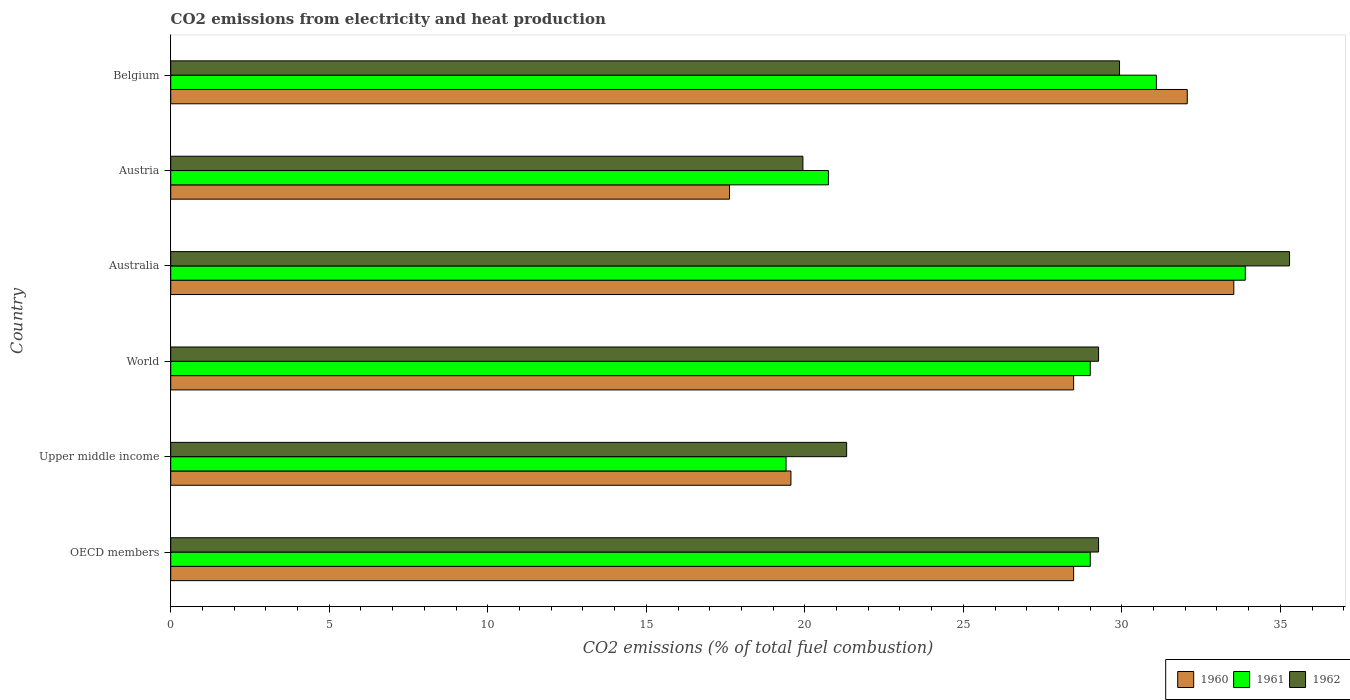How many different coloured bars are there?
Your answer should be very brief. 3. How many groups of bars are there?
Your answer should be very brief. 6. Are the number of bars on each tick of the Y-axis equal?
Provide a short and direct response. Yes. How many bars are there on the 5th tick from the top?
Provide a succinct answer. 3. What is the label of the 5th group of bars from the top?
Keep it short and to the point. Upper middle income. What is the amount of CO2 emitted in 1962 in OECD members?
Keep it short and to the point. 29.26. Across all countries, what is the maximum amount of CO2 emitted in 1961?
Your response must be concise. 33.89. Across all countries, what is the minimum amount of CO2 emitted in 1960?
Keep it short and to the point. 17.63. In which country was the amount of CO2 emitted in 1960 maximum?
Your answer should be very brief. Australia. In which country was the amount of CO2 emitted in 1962 minimum?
Provide a short and direct response. Austria. What is the total amount of CO2 emitted in 1961 in the graph?
Offer a terse response. 163.15. What is the difference between the amount of CO2 emitted in 1962 in Austria and that in Upper middle income?
Give a very brief answer. -1.38. What is the difference between the amount of CO2 emitted in 1960 in Upper middle income and the amount of CO2 emitted in 1961 in Austria?
Provide a succinct answer. -1.18. What is the average amount of CO2 emitted in 1960 per country?
Provide a succinct answer. 26.62. What is the difference between the amount of CO2 emitted in 1962 and amount of CO2 emitted in 1961 in Upper middle income?
Ensure brevity in your answer.  1.91. What is the ratio of the amount of CO2 emitted in 1962 in Australia to that in OECD members?
Give a very brief answer. 1.21. What is the difference between the highest and the second highest amount of CO2 emitted in 1962?
Offer a very short reply. 5.36. What is the difference between the highest and the lowest amount of CO2 emitted in 1960?
Keep it short and to the point. 15.91. What does the 3rd bar from the bottom in Upper middle income represents?
Your response must be concise. 1962. Is it the case that in every country, the sum of the amount of CO2 emitted in 1960 and amount of CO2 emitted in 1961 is greater than the amount of CO2 emitted in 1962?
Offer a very short reply. Yes. How many bars are there?
Provide a succinct answer. 18. How many countries are there in the graph?
Your answer should be compact. 6. Does the graph contain any zero values?
Offer a very short reply. No. Does the graph contain grids?
Your response must be concise. No. Where does the legend appear in the graph?
Offer a very short reply. Bottom right. What is the title of the graph?
Offer a terse response. CO2 emissions from electricity and heat production. What is the label or title of the X-axis?
Provide a succinct answer. CO2 emissions (% of total fuel combustion). What is the label or title of the Y-axis?
Offer a terse response. Country. What is the CO2 emissions (% of total fuel combustion) of 1960 in OECD members?
Ensure brevity in your answer.  28.48. What is the CO2 emissions (% of total fuel combustion) of 1961 in OECD members?
Keep it short and to the point. 29. What is the CO2 emissions (% of total fuel combustion) in 1962 in OECD members?
Keep it short and to the point. 29.26. What is the CO2 emissions (% of total fuel combustion) in 1960 in Upper middle income?
Offer a terse response. 19.56. What is the CO2 emissions (% of total fuel combustion) of 1961 in Upper middle income?
Ensure brevity in your answer.  19.41. What is the CO2 emissions (% of total fuel combustion) of 1962 in Upper middle income?
Your response must be concise. 21.32. What is the CO2 emissions (% of total fuel combustion) of 1960 in World?
Your answer should be very brief. 28.48. What is the CO2 emissions (% of total fuel combustion) in 1961 in World?
Ensure brevity in your answer.  29. What is the CO2 emissions (% of total fuel combustion) in 1962 in World?
Provide a succinct answer. 29.26. What is the CO2 emissions (% of total fuel combustion) in 1960 in Australia?
Your answer should be very brief. 33.53. What is the CO2 emissions (% of total fuel combustion) of 1961 in Australia?
Your response must be concise. 33.89. What is the CO2 emissions (% of total fuel combustion) of 1962 in Australia?
Provide a short and direct response. 35.29. What is the CO2 emissions (% of total fuel combustion) in 1960 in Austria?
Ensure brevity in your answer.  17.63. What is the CO2 emissions (% of total fuel combustion) in 1961 in Austria?
Offer a very short reply. 20.75. What is the CO2 emissions (% of total fuel combustion) in 1962 in Austria?
Keep it short and to the point. 19.94. What is the CO2 emissions (% of total fuel combustion) of 1960 in Belgium?
Your answer should be very brief. 32.06. What is the CO2 emissions (% of total fuel combustion) in 1961 in Belgium?
Provide a short and direct response. 31.09. What is the CO2 emissions (% of total fuel combustion) of 1962 in Belgium?
Offer a very short reply. 29.93. Across all countries, what is the maximum CO2 emissions (% of total fuel combustion) of 1960?
Your answer should be very brief. 33.53. Across all countries, what is the maximum CO2 emissions (% of total fuel combustion) of 1961?
Make the answer very short. 33.89. Across all countries, what is the maximum CO2 emissions (% of total fuel combustion) in 1962?
Keep it short and to the point. 35.29. Across all countries, what is the minimum CO2 emissions (% of total fuel combustion) of 1960?
Keep it short and to the point. 17.63. Across all countries, what is the minimum CO2 emissions (% of total fuel combustion) of 1961?
Your response must be concise. 19.41. Across all countries, what is the minimum CO2 emissions (% of total fuel combustion) in 1962?
Make the answer very short. 19.94. What is the total CO2 emissions (% of total fuel combustion) in 1960 in the graph?
Offer a very short reply. 159.74. What is the total CO2 emissions (% of total fuel combustion) in 1961 in the graph?
Your answer should be compact. 163.15. What is the total CO2 emissions (% of total fuel combustion) in 1962 in the graph?
Keep it short and to the point. 165.01. What is the difference between the CO2 emissions (% of total fuel combustion) of 1960 in OECD members and that in Upper middle income?
Make the answer very short. 8.92. What is the difference between the CO2 emissions (% of total fuel combustion) of 1961 in OECD members and that in Upper middle income?
Ensure brevity in your answer.  9.6. What is the difference between the CO2 emissions (% of total fuel combustion) of 1962 in OECD members and that in Upper middle income?
Your answer should be very brief. 7.95. What is the difference between the CO2 emissions (% of total fuel combustion) of 1962 in OECD members and that in World?
Make the answer very short. 0. What is the difference between the CO2 emissions (% of total fuel combustion) in 1960 in OECD members and that in Australia?
Make the answer very short. -5.05. What is the difference between the CO2 emissions (% of total fuel combustion) of 1961 in OECD members and that in Australia?
Give a very brief answer. -4.89. What is the difference between the CO2 emissions (% of total fuel combustion) of 1962 in OECD members and that in Australia?
Your response must be concise. -6.02. What is the difference between the CO2 emissions (% of total fuel combustion) of 1960 in OECD members and that in Austria?
Your response must be concise. 10.85. What is the difference between the CO2 emissions (% of total fuel combustion) of 1961 in OECD members and that in Austria?
Give a very brief answer. 8.26. What is the difference between the CO2 emissions (% of total fuel combustion) of 1962 in OECD members and that in Austria?
Provide a succinct answer. 9.33. What is the difference between the CO2 emissions (% of total fuel combustion) of 1960 in OECD members and that in Belgium?
Provide a short and direct response. -3.58. What is the difference between the CO2 emissions (% of total fuel combustion) in 1961 in OECD members and that in Belgium?
Keep it short and to the point. -2.09. What is the difference between the CO2 emissions (% of total fuel combustion) of 1962 in OECD members and that in Belgium?
Ensure brevity in your answer.  -0.66. What is the difference between the CO2 emissions (% of total fuel combustion) of 1960 in Upper middle income and that in World?
Provide a succinct answer. -8.92. What is the difference between the CO2 emissions (% of total fuel combustion) of 1961 in Upper middle income and that in World?
Give a very brief answer. -9.6. What is the difference between the CO2 emissions (% of total fuel combustion) of 1962 in Upper middle income and that in World?
Keep it short and to the point. -7.95. What is the difference between the CO2 emissions (% of total fuel combustion) in 1960 in Upper middle income and that in Australia?
Ensure brevity in your answer.  -13.97. What is the difference between the CO2 emissions (% of total fuel combustion) of 1961 in Upper middle income and that in Australia?
Your response must be concise. -14.49. What is the difference between the CO2 emissions (% of total fuel combustion) of 1962 in Upper middle income and that in Australia?
Offer a terse response. -13.97. What is the difference between the CO2 emissions (% of total fuel combustion) in 1960 in Upper middle income and that in Austria?
Your response must be concise. 1.94. What is the difference between the CO2 emissions (% of total fuel combustion) of 1961 in Upper middle income and that in Austria?
Provide a short and direct response. -1.34. What is the difference between the CO2 emissions (% of total fuel combustion) in 1962 in Upper middle income and that in Austria?
Your response must be concise. 1.38. What is the difference between the CO2 emissions (% of total fuel combustion) in 1960 in Upper middle income and that in Belgium?
Your answer should be compact. -12.5. What is the difference between the CO2 emissions (% of total fuel combustion) of 1961 in Upper middle income and that in Belgium?
Your answer should be very brief. -11.68. What is the difference between the CO2 emissions (% of total fuel combustion) in 1962 in Upper middle income and that in Belgium?
Your response must be concise. -8.61. What is the difference between the CO2 emissions (% of total fuel combustion) of 1960 in World and that in Australia?
Your response must be concise. -5.05. What is the difference between the CO2 emissions (% of total fuel combustion) of 1961 in World and that in Australia?
Make the answer very short. -4.89. What is the difference between the CO2 emissions (% of total fuel combustion) of 1962 in World and that in Australia?
Offer a very short reply. -6.02. What is the difference between the CO2 emissions (% of total fuel combustion) of 1960 in World and that in Austria?
Offer a very short reply. 10.85. What is the difference between the CO2 emissions (% of total fuel combustion) in 1961 in World and that in Austria?
Your answer should be compact. 8.26. What is the difference between the CO2 emissions (% of total fuel combustion) in 1962 in World and that in Austria?
Your answer should be compact. 9.33. What is the difference between the CO2 emissions (% of total fuel combustion) in 1960 in World and that in Belgium?
Ensure brevity in your answer.  -3.58. What is the difference between the CO2 emissions (% of total fuel combustion) in 1961 in World and that in Belgium?
Give a very brief answer. -2.09. What is the difference between the CO2 emissions (% of total fuel combustion) in 1962 in World and that in Belgium?
Your answer should be compact. -0.66. What is the difference between the CO2 emissions (% of total fuel combustion) in 1960 in Australia and that in Austria?
Keep it short and to the point. 15.91. What is the difference between the CO2 emissions (% of total fuel combustion) in 1961 in Australia and that in Austria?
Offer a terse response. 13.15. What is the difference between the CO2 emissions (% of total fuel combustion) in 1962 in Australia and that in Austria?
Provide a short and direct response. 15.35. What is the difference between the CO2 emissions (% of total fuel combustion) of 1960 in Australia and that in Belgium?
Offer a terse response. 1.47. What is the difference between the CO2 emissions (% of total fuel combustion) in 1961 in Australia and that in Belgium?
Your answer should be compact. 2.8. What is the difference between the CO2 emissions (% of total fuel combustion) of 1962 in Australia and that in Belgium?
Keep it short and to the point. 5.36. What is the difference between the CO2 emissions (% of total fuel combustion) of 1960 in Austria and that in Belgium?
Give a very brief answer. -14.44. What is the difference between the CO2 emissions (% of total fuel combustion) in 1961 in Austria and that in Belgium?
Your answer should be compact. -10.34. What is the difference between the CO2 emissions (% of total fuel combustion) in 1962 in Austria and that in Belgium?
Provide a short and direct response. -9.99. What is the difference between the CO2 emissions (% of total fuel combustion) of 1960 in OECD members and the CO2 emissions (% of total fuel combustion) of 1961 in Upper middle income?
Give a very brief answer. 9.07. What is the difference between the CO2 emissions (% of total fuel combustion) of 1960 in OECD members and the CO2 emissions (% of total fuel combustion) of 1962 in Upper middle income?
Offer a very short reply. 7.16. What is the difference between the CO2 emissions (% of total fuel combustion) of 1961 in OECD members and the CO2 emissions (% of total fuel combustion) of 1962 in Upper middle income?
Provide a succinct answer. 7.68. What is the difference between the CO2 emissions (% of total fuel combustion) in 1960 in OECD members and the CO2 emissions (% of total fuel combustion) in 1961 in World?
Your answer should be compact. -0.52. What is the difference between the CO2 emissions (% of total fuel combustion) in 1960 in OECD members and the CO2 emissions (% of total fuel combustion) in 1962 in World?
Your answer should be very brief. -0.79. What is the difference between the CO2 emissions (% of total fuel combustion) in 1961 in OECD members and the CO2 emissions (% of total fuel combustion) in 1962 in World?
Ensure brevity in your answer.  -0.26. What is the difference between the CO2 emissions (% of total fuel combustion) in 1960 in OECD members and the CO2 emissions (% of total fuel combustion) in 1961 in Australia?
Make the answer very short. -5.41. What is the difference between the CO2 emissions (% of total fuel combustion) in 1960 in OECD members and the CO2 emissions (% of total fuel combustion) in 1962 in Australia?
Your answer should be compact. -6.81. What is the difference between the CO2 emissions (% of total fuel combustion) of 1961 in OECD members and the CO2 emissions (% of total fuel combustion) of 1962 in Australia?
Offer a very short reply. -6.29. What is the difference between the CO2 emissions (% of total fuel combustion) in 1960 in OECD members and the CO2 emissions (% of total fuel combustion) in 1961 in Austria?
Provide a succinct answer. 7.73. What is the difference between the CO2 emissions (% of total fuel combustion) of 1960 in OECD members and the CO2 emissions (% of total fuel combustion) of 1962 in Austria?
Offer a terse response. 8.54. What is the difference between the CO2 emissions (% of total fuel combustion) in 1961 in OECD members and the CO2 emissions (% of total fuel combustion) in 1962 in Austria?
Offer a very short reply. 9.06. What is the difference between the CO2 emissions (% of total fuel combustion) of 1960 in OECD members and the CO2 emissions (% of total fuel combustion) of 1961 in Belgium?
Provide a succinct answer. -2.61. What is the difference between the CO2 emissions (% of total fuel combustion) in 1960 in OECD members and the CO2 emissions (% of total fuel combustion) in 1962 in Belgium?
Offer a very short reply. -1.45. What is the difference between the CO2 emissions (% of total fuel combustion) of 1961 in OECD members and the CO2 emissions (% of total fuel combustion) of 1962 in Belgium?
Keep it short and to the point. -0.92. What is the difference between the CO2 emissions (% of total fuel combustion) of 1960 in Upper middle income and the CO2 emissions (% of total fuel combustion) of 1961 in World?
Provide a succinct answer. -9.44. What is the difference between the CO2 emissions (% of total fuel combustion) of 1960 in Upper middle income and the CO2 emissions (% of total fuel combustion) of 1962 in World?
Provide a succinct answer. -9.7. What is the difference between the CO2 emissions (% of total fuel combustion) of 1961 in Upper middle income and the CO2 emissions (% of total fuel combustion) of 1962 in World?
Offer a very short reply. -9.86. What is the difference between the CO2 emissions (% of total fuel combustion) of 1960 in Upper middle income and the CO2 emissions (% of total fuel combustion) of 1961 in Australia?
Your answer should be very brief. -14.33. What is the difference between the CO2 emissions (% of total fuel combustion) in 1960 in Upper middle income and the CO2 emissions (% of total fuel combustion) in 1962 in Australia?
Your answer should be very brief. -15.73. What is the difference between the CO2 emissions (% of total fuel combustion) of 1961 in Upper middle income and the CO2 emissions (% of total fuel combustion) of 1962 in Australia?
Your answer should be compact. -15.88. What is the difference between the CO2 emissions (% of total fuel combustion) in 1960 in Upper middle income and the CO2 emissions (% of total fuel combustion) in 1961 in Austria?
Give a very brief answer. -1.18. What is the difference between the CO2 emissions (% of total fuel combustion) of 1960 in Upper middle income and the CO2 emissions (% of total fuel combustion) of 1962 in Austria?
Make the answer very short. -0.38. What is the difference between the CO2 emissions (% of total fuel combustion) of 1961 in Upper middle income and the CO2 emissions (% of total fuel combustion) of 1962 in Austria?
Your answer should be very brief. -0.53. What is the difference between the CO2 emissions (% of total fuel combustion) of 1960 in Upper middle income and the CO2 emissions (% of total fuel combustion) of 1961 in Belgium?
Provide a short and direct response. -11.53. What is the difference between the CO2 emissions (% of total fuel combustion) in 1960 in Upper middle income and the CO2 emissions (% of total fuel combustion) in 1962 in Belgium?
Make the answer very short. -10.36. What is the difference between the CO2 emissions (% of total fuel combustion) in 1961 in Upper middle income and the CO2 emissions (% of total fuel combustion) in 1962 in Belgium?
Your answer should be compact. -10.52. What is the difference between the CO2 emissions (% of total fuel combustion) in 1960 in World and the CO2 emissions (% of total fuel combustion) in 1961 in Australia?
Provide a short and direct response. -5.41. What is the difference between the CO2 emissions (% of total fuel combustion) of 1960 in World and the CO2 emissions (% of total fuel combustion) of 1962 in Australia?
Provide a succinct answer. -6.81. What is the difference between the CO2 emissions (% of total fuel combustion) of 1961 in World and the CO2 emissions (% of total fuel combustion) of 1962 in Australia?
Your answer should be very brief. -6.29. What is the difference between the CO2 emissions (% of total fuel combustion) of 1960 in World and the CO2 emissions (% of total fuel combustion) of 1961 in Austria?
Ensure brevity in your answer.  7.73. What is the difference between the CO2 emissions (% of total fuel combustion) of 1960 in World and the CO2 emissions (% of total fuel combustion) of 1962 in Austria?
Keep it short and to the point. 8.54. What is the difference between the CO2 emissions (% of total fuel combustion) in 1961 in World and the CO2 emissions (% of total fuel combustion) in 1962 in Austria?
Ensure brevity in your answer.  9.06. What is the difference between the CO2 emissions (% of total fuel combustion) in 1960 in World and the CO2 emissions (% of total fuel combustion) in 1961 in Belgium?
Give a very brief answer. -2.61. What is the difference between the CO2 emissions (% of total fuel combustion) of 1960 in World and the CO2 emissions (% of total fuel combustion) of 1962 in Belgium?
Provide a succinct answer. -1.45. What is the difference between the CO2 emissions (% of total fuel combustion) in 1961 in World and the CO2 emissions (% of total fuel combustion) in 1962 in Belgium?
Offer a very short reply. -0.92. What is the difference between the CO2 emissions (% of total fuel combustion) of 1960 in Australia and the CO2 emissions (% of total fuel combustion) of 1961 in Austria?
Offer a terse response. 12.79. What is the difference between the CO2 emissions (% of total fuel combustion) of 1960 in Australia and the CO2 emissions (% of total fuel combustion) of 1962 in Austria?
Your answer should be very brief. 13.59. What is the difference between the CO2 emissions (% of total fuel combustion) in 1961 in Australia and the CO2 emissions (% of total fuel combustion) in 1962 in Austria?
Provide a short and direct response. 13.95. What is the difference between the CO2 emissions (% of total fuel combustion) in 1960 in Australia and the CO2 emissions (% of total fuel combustion) in 1961 in Belgium?
Provide a succinct answer. 2.44. What is the difference between the CO2 emissions (% of total fuel combustion) in 1960 in Australia and the CO2 emissions (% of total fuel combustion) in 1962 in Belgium?
Your answer should be compact. 3.6. What is the difference between the CO2 emissions (% of total fuel combustion) of 1961 in Australia and the CO2 emissions (% of total fuel combustion) of 1962 in Belgium?
Give a very brief answer. 3.97. What is the difference between the CO2 emissions (% of total fuel combustion) in 1960 in Austria and the CO2 emissions (% of total fuel combustion) in 1961 in Belgium?
Give a very brief answer. -13.46. What is the difference between the CO2 emissions (% of total fuel combustion) of 1960 in Austria and the CO2 emissions (% of total fuel combustion) of 1962 in Belgium?
Provide a short and direct response. -12.3. What is the difference between the CO2 emissions (% of total fuel combustion) in 1961 in Austria and the CO2 emissions (% of total fuel combustion) in 1962 in Belgium?
Offer a terse response. -9.18. What is the average CO2 emissions (% of total fuel combustion) of 1960 per country?
Give a very brief answer. 26.62. What is the average CO2 emissions (% of total fuel combustion) in 1961 per country?
Give a very brief answer. 27.19. What is the average CO2 emissions (% of total fuel combustion) in 1962 per country?
Your response must be concise. 27.5. What is the difference between the CO2 emissions (% of total fuel combustion) in 1960 and CO2 emissions (% of total fuel combustion) in 1961 in OECD members?
Provide a short and direct response. -0.52. What is the difference between the CO2 emissions (% of total fuel combustion) in 1960 and CO2 emissions (% of total fuel combustion) in 1962 in OECD members?
Ensure brevity in your answer.  -0.79. What is the difference between the CO2 emissions (% of total fuel combustion) in 1961 and CO2 emissions (% of total fuel combustion) in 1962 in OECD members?
Keep it short and to the point. -0.26. What is the difference between the CO2 emissions (% of total fuel combustion) in 1960 and CO2 emissions (% of total fuel combustion) in 1961 in Upper middle income?
Make the answer very short. 0.15. What is the difference between the CO2 emissions (% of total fuel combustion) in 1960 and CO2 emissions (% of total fuel combustion) in 1962 in Upper middle income?
Make the answer very short. -1.76. What is the difference between the CO2 emissions (% of total fuel combustion) of 1961 and CO2 emissions (% of total fuel combustion) of 1962 in Upper middle income?
Provide a succinct answer. -1.91. What is the difference between the CO2 emissions (% of total fuel combustion) in 1960 and CO2 emissions (% of total fuel combustion) in 1961 in World?
Provide a succinct answer. -0.52. What is the difference between the CO2 emissions (% of total fuel combustion) in 1960 and CO2 emissions (% of total fuel combustion) in 1962 in World?
Offer a terse response. -0.79. What is the difference between the CO2 emissions (% of total fuel combustion) of 1961 and CO2 emissions (% of total fuel combustion) of 1962 in World?
Give a very brief answer. -0.26. What is the difference between the CO2 emissions (% of total fuel combustion) of 1960 and CO2 emissions (% of total fuel combustion) of 1961 in Australia?
Provide a succinct answer. -0.36. What is the difference between the CO2 emissions (% of total fuel combustion) in 1960 and CO2 emissions (% of total fuel combustion) in 1962 in Australia?
Offer a terse response. -1.76. What is the difference between the CO2 emissions (% of total fuel combustion) in 1961 and CO2 emissions (% of total fuel combustion) in 1962 in Australia?
Make the answer very short. -1.4. What is the difference between the CO2 emissions (% of total fuel combustion) of 1960 and CO2 emissions (% of total fuel combustion) of 1961 in Austria?
Offer a very short reply. -3.12. What is the difference between the CO2 emissions (% of total fuel combustion) in 1960 and CO2 emissions (% of total fuel combustion) in 1962 in Austria?
Your response must be concise. -2.31. What is the difference between the CO2 emissions (% of total fuel combustion) in 1961 and CO2 emissions (% of total fuel combustion) in 1962 in Austria?
Provide a succinct answer. 0.81. What is the difference between the CO2 emissions (% of total fuel combustion) in 1960 and CO2 emissions (% of total fuel combustion) in 1961 in Belgium?
Give a very brief answer. 0.97. What is the difference between the CO2 emissions (% of total fuel combustion) in 1960 and CO2 emissions (% of total fuel combustion) in 1962 in Belgium?
Provide a short and direct response. 2.14. What is the difference between the CO2 emissions (% of total fuel combustion) in 1961 and CO2 emissions (% of total fuel combustion) in 1962 in Belgium?
Offer a terse response. 1.16. What is the ratio of the CO2 emissions (% of total fuel combustion) of 1960 in OECD members to that in Upper middle income?
Your response must be concise. 1.46. What is the ratio of the CO2 emissions (% of total fuel combustion) of 1961 in OECD members to that in Upper middle income?
Your answer should be very brief. 1.49. What is the ratio of the CO2 emissions (% of total fuel combustion) in 1962 in OECD members to that in Upper middle income?
Your response must be concise. 1.37. What is the ratio of the CO2 emissions (% of total fuel combustion) in 1960 in OECD members to that in World?
Your answer should be very brief. 1. What is the ratio of the CO2 emissions (% of total fuel combustion) of 1962 in OECD members to that in World?
Keep it short and to the point. 1. What is the ratio of the CO2 emissions (% of total fuel combustion) in 1960 in OECD members to that in Australia?
Keep it short and to the point. 0.85. What is the ratio of the CO2 emissions (% of total fuel combustion) of 1961 in OECD members to that in Australia?
Ensure brevity in your answer.  0.86. What is the ratio of the CO2 emissions (% of total fuel combustion) of 1962 in OECD members to that in Australia?
Your answer should be very brief. 0.83. What is the ratio of the CO2 emissions (% of total fuel combustion) in 1960 in OECD members to that in Austria?
Your answer should be very brief. 1.62. What is the ratio of the CO2 emissions (% of total fuel combustion) in 1961 in OECD members to that in Austria?
Your answer should be very brief. 1.4. What is the ratio of the CO2 emissions (% of total fuel combustion) of 1962 in OECD members to that in Austria?
Your answer should be compact. 1.47. What is the ratio of the CO2 emissions (% of total fuel combustion) of 1960 in OECD members to that in Belgium?
Your response must be concise. 0.89. What is the ratio of the CO2 emissions (% of total fuel combustion) in 1961 in OECD members to that in Belgium?
Your response must be concise. 0.93. What is the ratio of the CO2 emissions (% of total fuel combustion) of 1962 in OECD members to that in Belgium?
Your answer should be very brief. 0.98. What is the ratio of the CO2 emissions (% of total fuel combustion) of 1960 in Upper middle income to that in World?
Give a very brief answer. 0.69. What is the ratio of the CO2 emissions (% of total fuel combustion) of 1961 in Upper middle income to that in World?
Provide a succinct answer. 0.67. What is the ratio of the CO2 emissions (% of total fuel combustion) of 1962 in Upper middle income to that in World?
Your answer should be very brief. 0.73. What is the ratio of the CO2 emissions (% of total fuel combustion) in 1960 in Upper middle income to that in Australia?
Provide a succinct answer. 0.58. What is the ratio of the CO2 emissions (% of total fuel combustion) in 1961 in Upper middle income to that in Australia?
Offer a very short reply. 0.57. What is the ratio of the CO2 emissions (% of total fuel combustion) in 1962 in Upper middle income to that in Australia?
Your response must be concise. 0.6. What is the ratio of the CO2 emissions (% of total fuel combustion) in 1960 in Upper middle income to that in Austria?
Your answer should be compact. 1.11. What is the ratio of the CO2 emissions (% of total fuel combustion) of 1961 in Upper middle income to that in Austria?
Ensure brevity in your answer.  0.94. What is the ratio of the CO2 emissions (% of total fuel combustion) in 1962 in Upper middle income to that in Austria?
Your answer should be very brief. 1.07. What is the ratio of the CO2 emissions (% of total fuel combustion) of 1960 in Upper middle income to that in Belgium?
Offer a very short reply. 0.61. What is the ratio of the CO2 emissions (% of total fuel combustion) in 1961 in Upper middle income to that in Belgium?
Give a very brief answer. 0.62. What is the ratio of the CO2 emissions (% of total fuel combustion) in 1962 in Upper middle income to that in Belgium?
Provide a succinct answer. 0.71. What is the ratio of the CO2 emissions (% of total fuel combustion) of 1960 in World to that in Australia?
Keep it short and to the point. 0.85. What is the ratio of the CO2 emissions (% of total fuel combustion) in 1961 in World to that in Australia?
Make the answer very short. 0.86. What is the ratio of the CO2 emissions (% of total fuel combustion) of 1962 in World to that in Australia?
Make the answer very short. 0.83. What is the ratio of the CO2 emissions (% of total fuel combustion) of 1960 in World to that in Austria?
Your answer should be compact. 1.62. What is the ratio of the CO2 emissions (% of total fuel combustion) of 1961 in World to that in Austria?
Offer a terse response. 1.4. What is the ratio of the CO2 emissions (% of total fuel combustion) in 1962 in World to that in Austria?
Offer a terse response. 1.47. What is the ratio of the CO2 emissions (% of total fuel combustion) in 1960 in World to that in Belgium?
Offer a very short reply. 0.89. What is the ratio of the CO2 emissions (% of total fuel combustion) of 1961 in World to that in Belgium?
Offer a terse response. 0.93. What is the ratio of the CO2 emissions (% of total fuel combustion) of 1962 in World to that in Belgium?
Give a very brief answer. 0.98. What is the ratio of the CO2 emissions (% of total fuel combustion) of 1960 in Australia to that in Austria?
Provide a short and direct response. 1.9. What is the ratio of the CO2 emissions (% of total fuel combustion) in 1961 in Australia to that in Austria?
Make the answer very short. 1.63. What is the ratio of the CO2 emissions (% of total fuel combustion) in 1962 in Australia to that in Austria?
Your answer should be compact. 1.77. What is the ratio of the CO2 emissions (% of total fuel combustion) in 1960 in Australia to that in Belgium?
Ensure brevity in your answer.  1.05. What is the ratio of the CO2 emissions (% of total fuel combustion) of 1961 in Australia to that in Belgium?
Make the answer very short. 1.09. What is the ratio of the CO2 emissions (% of total fuel combustion) of 1962 in Australia to that in Belgium?
Provide a short and direct response. 1.18. What is the ratio of the CO2 emissions (% of total fuel combustion) of 1960 in Austria to that in Belgium?
Ensure brevity in your answer.  0.55. What is the ratio of the CO2 emissions (% of total fuel combustion) in 1961 in Austria to that in Belgium?
Your response must be concise. 0.67. What is the ratio of the CO2 emissions (% of total fuel combustion) in 1962 in Austria to that in Belgium?
Your response must be concise. 0.67. What is the difference between the highest and the second highest CO2 emissions (% of total fuel combustion) in 1960?
Give a very brief answer. 1.47. What is the difference between the highest and the second highest CO2 emissions (% of total fuel combustion) of 1961?
Your answer should be very brief. 2.8. What is the difference between the highest and the second highest CO2 emissions (% of total fuel combustion) in 1962?
Your answer should be compact. 5.36. What is the difference between the highest and the lowest CO2 emissions (% of total fuel combustion) in 1960?
Your response must be concise. 15.91. What is the difference between the highest and the lowest CO2 emissions (% of total fuel combustion) in 1961?
Your answer should be compact. 14.49. What is the difference between the highest and the lowest CO2 emissions (% of total fuel combustion) of 1962?
Provide a succinct answer. 15.35. 